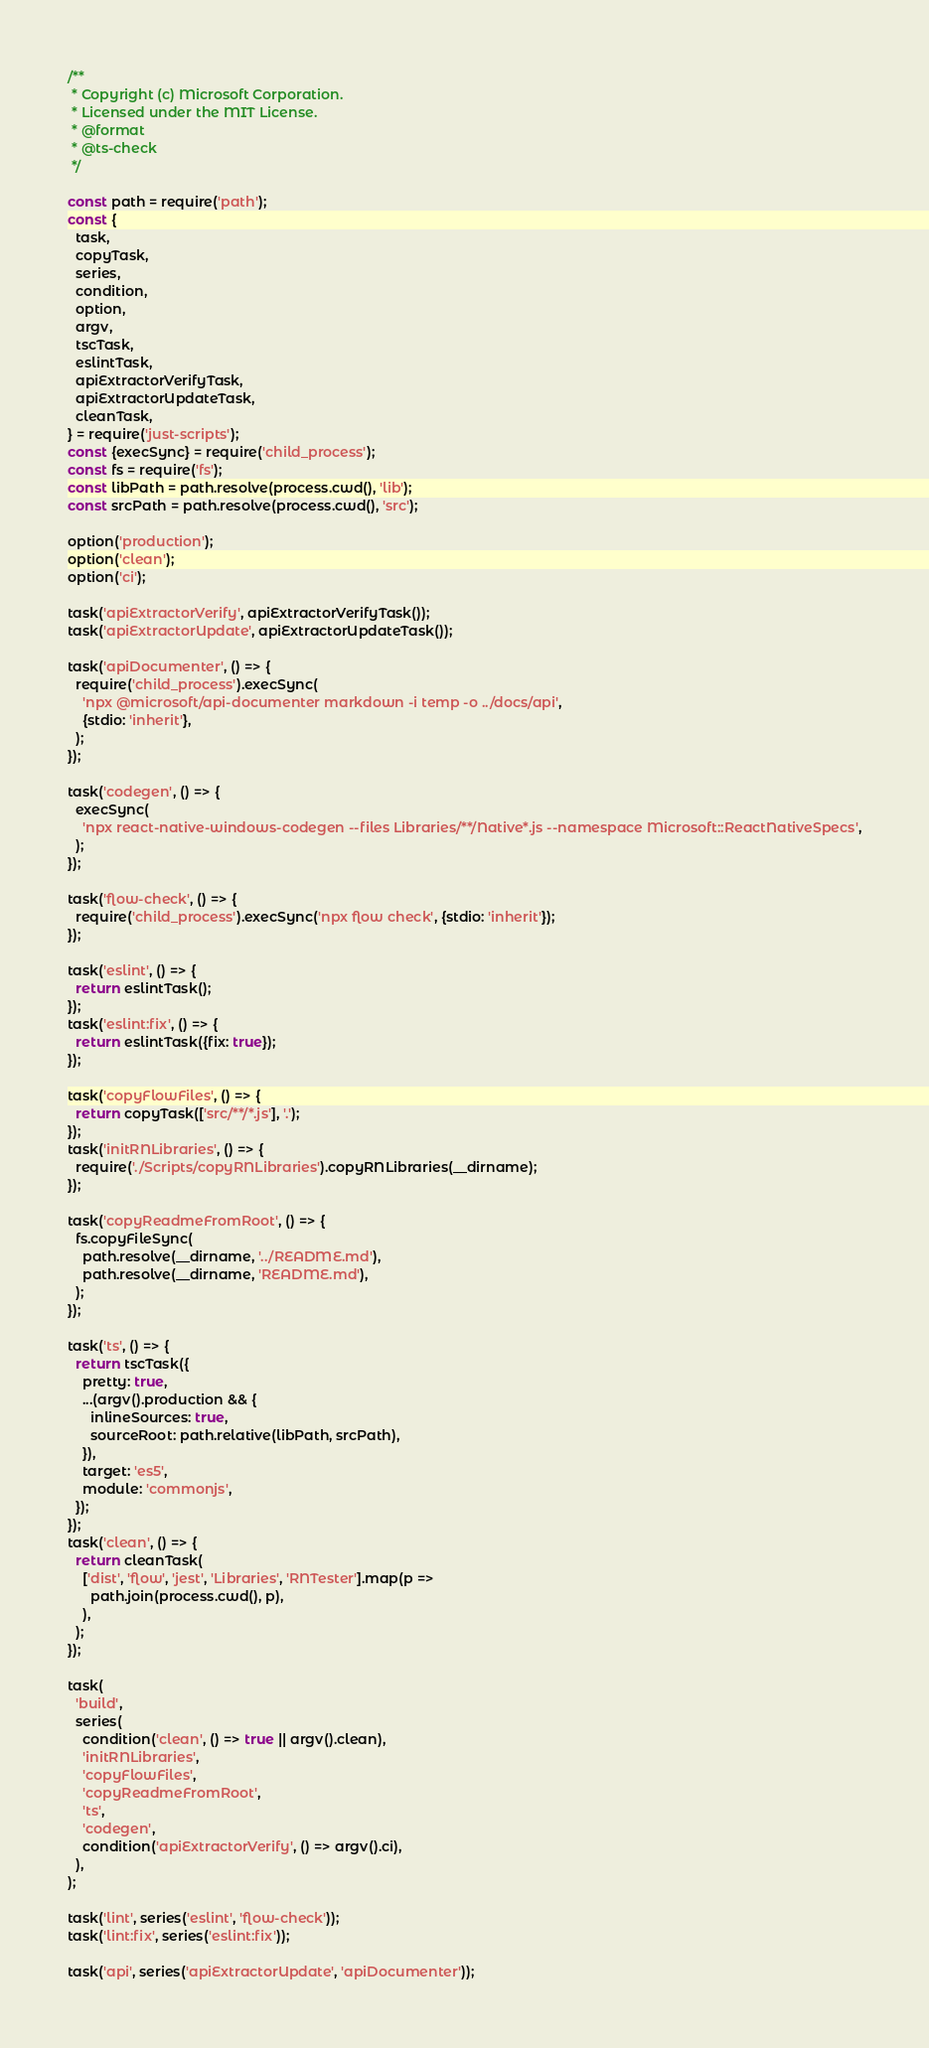<code> <loc_0><loc_0><loc_500><loc_500><_JavaScript_>/**
 * Copyright (c) Microsoft Corporation.
 * Licensed under the MIT License.
 * @format
 * @ts-check
 */

const path = require('path');
const {
  task,
  copyTask,
  series,
  condition,
  option,
  argv,
  tscTask,
  eslintTask,
  apiExtractorVerifyTask,
  apiExtractorUpdateTask,
  cleanTask,
} = require('just-scripts');
const {execSync} = require('child_process');
const fs = require('fs');
const libPath = path.resolve(process.cwd(), 'lib');
const srcPath = path.resolve(process.cwd(), 'src');

option('production');
option('clean');
option('ci');

task('apiExtractorVerify', apiExtractorVerifyTask());
task('apiExtractorUpdate', apiExtractorUpdateTask());

task('apiDocumenter', () => {
  require('child_process').execSync(
    'npx @microsoft/api-documenter markdown -i temp -o ../docs/api',
    {stdio: 'inherit'},
  );
});

task('codegen', () => {
  execSync(
    'npx react-native-windows-codegen --files Libraries/**/Native*.js --namespace Microsoft::ReactNativeSpecs',
  );
});

task('flow-check', () => {
  require('child_process').execSync('npx flow check', {stdio: 'inherit'});
});

task('eslint', () => {
  return eslintTask();
});
task('eslint:fix', () => {
  return eslintTask({fix: true});
});

task('copyFlowFiles', () => {
  return copyTask(['src/**/*.js'], '.');
});
task('initRNLibraries', () => {
  require('./Scripts/copyRNLibraries').copyRNLibraries(__dirname);
});

task('copyReadmeFromRoot', () => {
  fs.copyFileSync(
    path.resolve(__dirname, '../README.md'),
    path.resolve(__dirname, 'README.md'),
  );
});

task('ts', () => {
  return tscTask({
    pretty: true,
    ...(argv().production && {
      inlineSources: true,
      sourceRoot: path.relative(libPath, srcPath),
    }),
    target: 'es5',
    module: 'commonjs',
  });
});
task('clean', () => {
  return cleanTask(
    ['dist', 'flow', 'jest', 'Libraries', 'RNTester'].map(p =>
      path.join(process.cwd(), p),
    ),
  );
});

task(
  'build',
  series(
    condition('clean', () => true || argv().clean),
    'initRNLibraries',
    'copyFlowFiles',
    'copyReadmeFromRoot',
    'ts',
    'codegen',
    condition('apiExtractorVerify', () => argv().ci),
  ),
);

task('lint', series('eslint', 'flow-check'));
task('lint:fix', series('eslint:fix'));

task('api', series('apiExtractorUpdate', 'apiDocumenter'));
</code> 